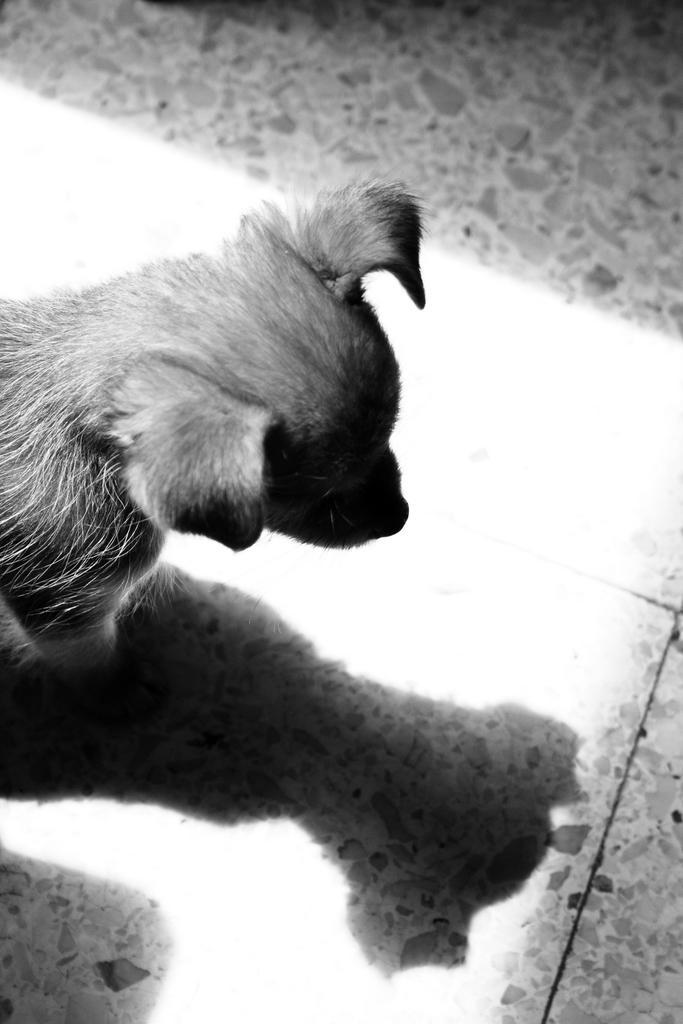Can you describe this image briefly? In the picture we can see a dog on the floor looking its image in the title. 